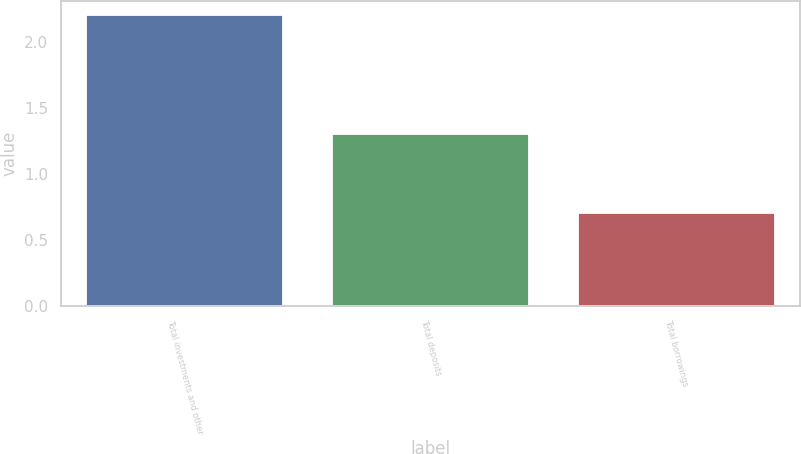<chart> <loc_0><loc_0><loc_500><loc_500><bar_chart><fcel>Total investments and other<fcel>Total deposits<fcel>Total borrowings<nl><fcel>2.2<fcel>1.3<fcel>0.7<nl></chart> 